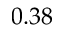<formula> <loc_0><loc_0><loc_500><loc_500>0 . 3 8</formula> 